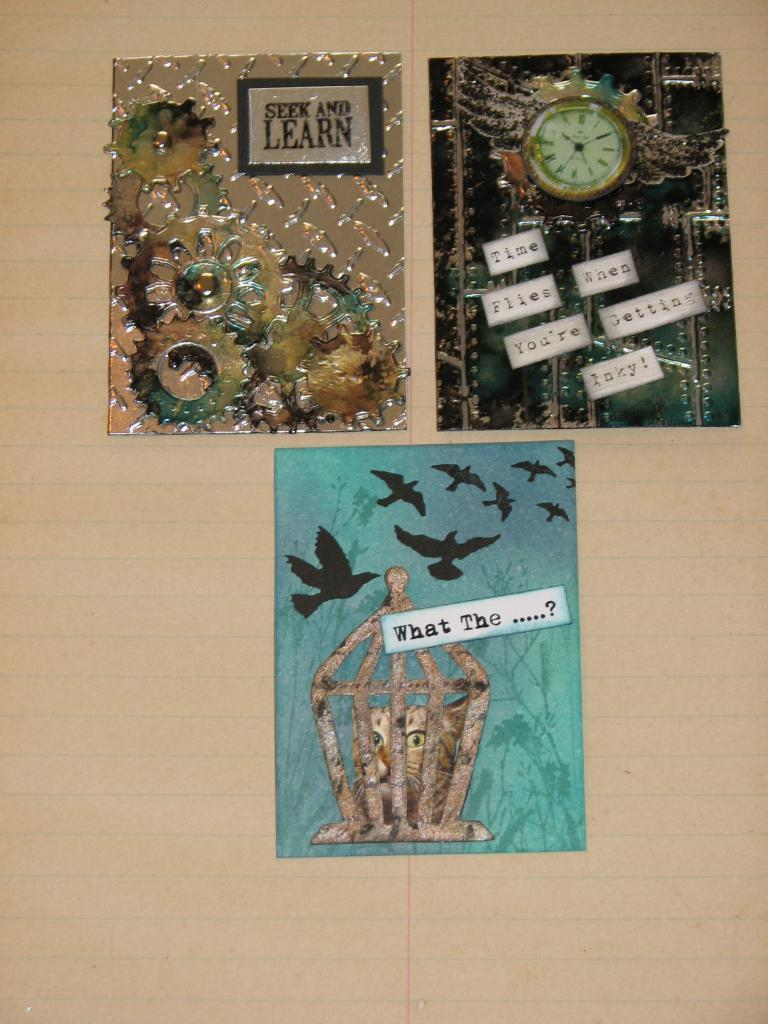<image>
Provide a brief description of the given image. Motivational pictures on the wall say Seek and Learn, Time flies when you're getting inky! and What the .. 